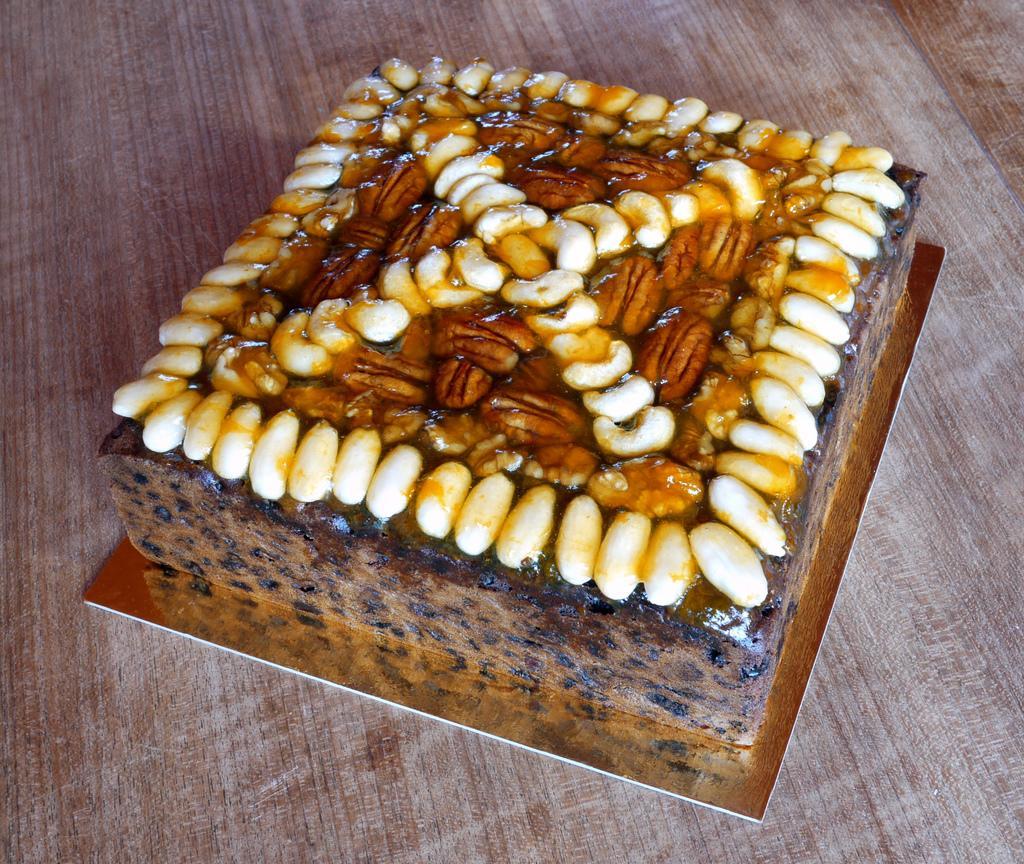Could you give a brief overview of what you see in this image? There is a cake with dry fruits on a cake base. It is on a wooden surface. 